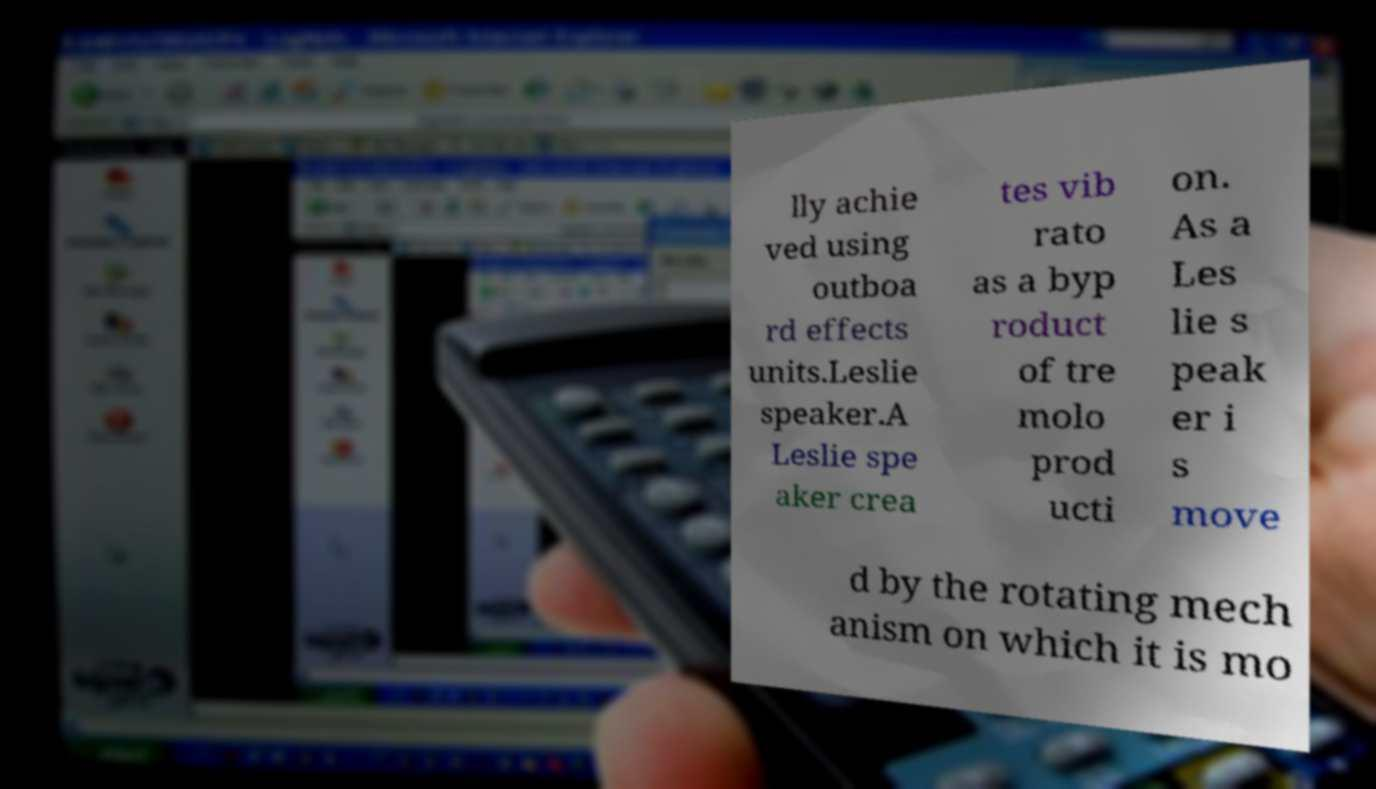Please identify and transcribe the text found in this image. lly achie ved using outboa rd effects units.Leslie speaker.A Leslie spe aker crea tes vib rato as a byp roduct of tre molo prod ucti on. As a Les lie s peak er i s move d by the rotating mech anism on which it is mo 